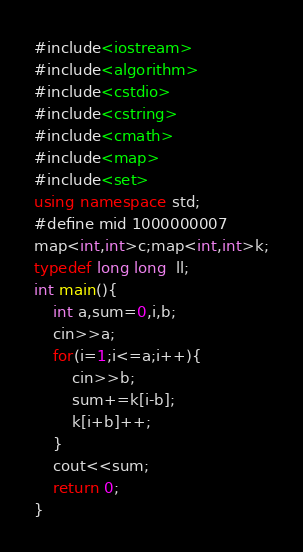<code> <loc_0><loc_0><loc_500><loc_500><_C++_>#include<iostream>
#include<algorithm>
#include<cstdio>
#include<cstring>
#include<cmath>
#include<map> 
#include<set> 
using namespace std;
#define mid 1000000007
map<int,int>c;map<int,int>k;
typedef long long  ll;
int main(){
	int a,sum=0,i,b;
	cin>>a;
	for(i=1;i<=a;i++){
		cin>>b;
		sum+=k[i-b]; 
		k[i+b]++;
	}
	cout<<sum;
	return 0;
}</code> 